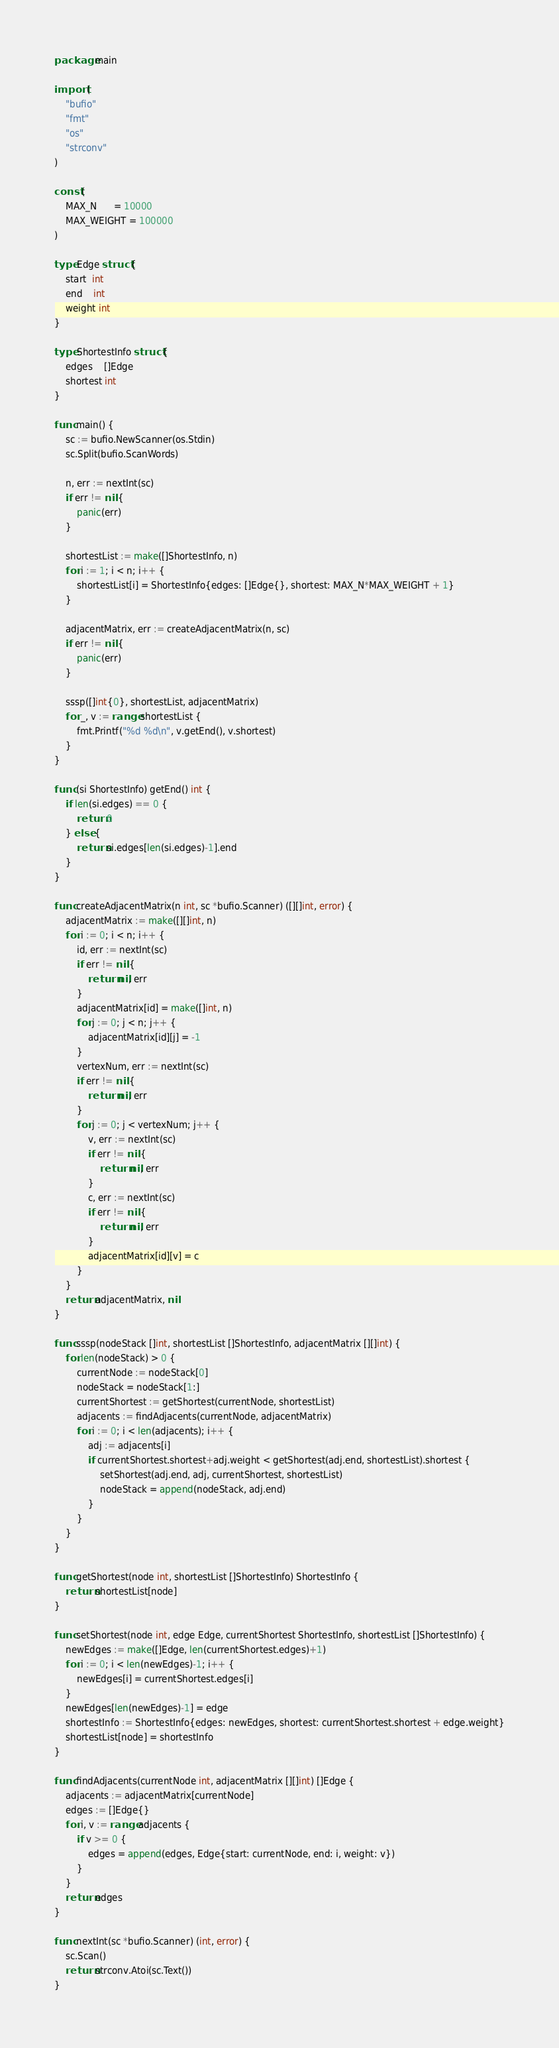<code> <loc_0><loc_0><loc_500><loc_500><_Go_>package main

import (
	"bufio"
	"fmt"
	"os"
	"strconv"
)

const (
	MAX_N      = 10000
	MAX_WEIGHT = 100000
)

type Edge struct {
	start  int
	end    int
	weight int
}

type ShortestInfo struct {
	edges    []Edge
	shortest int
}

func main() {
	sc := bufio.NewScanner(os.Stdin)
	sc.Split(bufio.ScanWords)

	n, err := nextInt(sc)
	if err != nil {
		panic(err)
	}

	shortestList := make([]ShortestInfo, n)
	for i := 1; i < n; i++ {
		shortestList[i] = ShortestInfo{edges: []Edge{}, shortest: MAX_N*MAX_WEIGHT + 1}
	}

	adjacentMatrix, err := createAdjacentMatrix(n, sc)
	if err != nil {
		panic(err)
	}

	sssp([]int{0}, shortestList, adjacentMatrix)
	for _, v := range shortestList {
		fmt.Printf("%d %d\n", v.getEnd(), v.shortest)
	}
}

func (si ShortestInfo) getEnd() int {
	if len(si.edges) == 0 {
		return 0
	} else {
		return si.edges[len(si.edges)-1].end
	}
}

func createAdjacentMatrix(n int, sc *bufio.Scanner) ([][]int, error) {
	adjacentMatrix := make([][]int, n)
	for i := 0; i < n; i++ {
		id, err := nextInt(sc)
		if err != nil {
			return nil, err
		}
		adjacentMatrix[id] = make([]int, n)
		for j := 0; j < n; j++ {
			adjacentMatrix[id][j] = -1
		}
		vertexNum, err := nextInt(sc)
		if err != nil {
			return nil, err
		}
		for j := 0; j < vertexNum; j++ {
			v, err := nextInt(sc)
			if err != nil {
				return nil, err
			}
			c, err := nextInt(sc)
			if err != nil {
				return nil, err
			}
			adjacentMatrix[id][v] = c
		}
	}
	return adjacentMatrix, nil
}

func sssp(nodeStack []int, shortestList []ShortestInfo, adjacentMatrix [][]int) {
	for len(nodeStack) > 0 {
		currentNode := nodeStack[0]
		nodeStack = nodeStack[1:]
		currentShortest := getShortest(currentNode, shortestList)
		adjacents := findAdjacents(currentNode, adjacentMatrix)
		for i := 0; i < len(adjacents); i++ {
			adj := adjacents[i]
			if currentShortest.shortest+adj.weight < getShortest(adj.end, shortestList).shortest {
				setShortest(adj.end, adj, currentShortest, shortestList)
				nodeStack = append(nodeStack, adj.end)
			}
		}
	}
}

func getShortest(node int, shortestList []ShortestInfo) ShortestInfo {
	return shortestList[node]
}

func setShortest(node int, edge Edge, currentShortest ShortestInfo, shortestList []ShortestInfo) {
	newEdges := make([]Edge, len(currentShortest.edges)+1)
	for i := 0; i < len(newEdges)-1; i++ {
		newEdges[i] = currentShortest.edges[i]
	}
	newEdges[len(newEdges)-1] = edge
	shortestInfo := ShortestInfo{edges: newEdges, shortest: currentShortest.shortest + edge.weight}
	shortestList[node] = shortestInfo
}

func findAdjacents(currentNode int, adjacentMatrix [][]int) []Edge {
	adjacents := adjacentMatrix[currentNode]
	edges := []Edge{}
	for i, v := range adjacents {
		if v >= 0 {
			edges = append(edges, Edge{start: currentNode, end: i, weight: v})
		}
	}
	return edges
}

func nextInt(sc *bufio.Scanner) (int, error) {
	sc.Scan()
	return strconv.Atoi(sc.Text())
}

</code> 